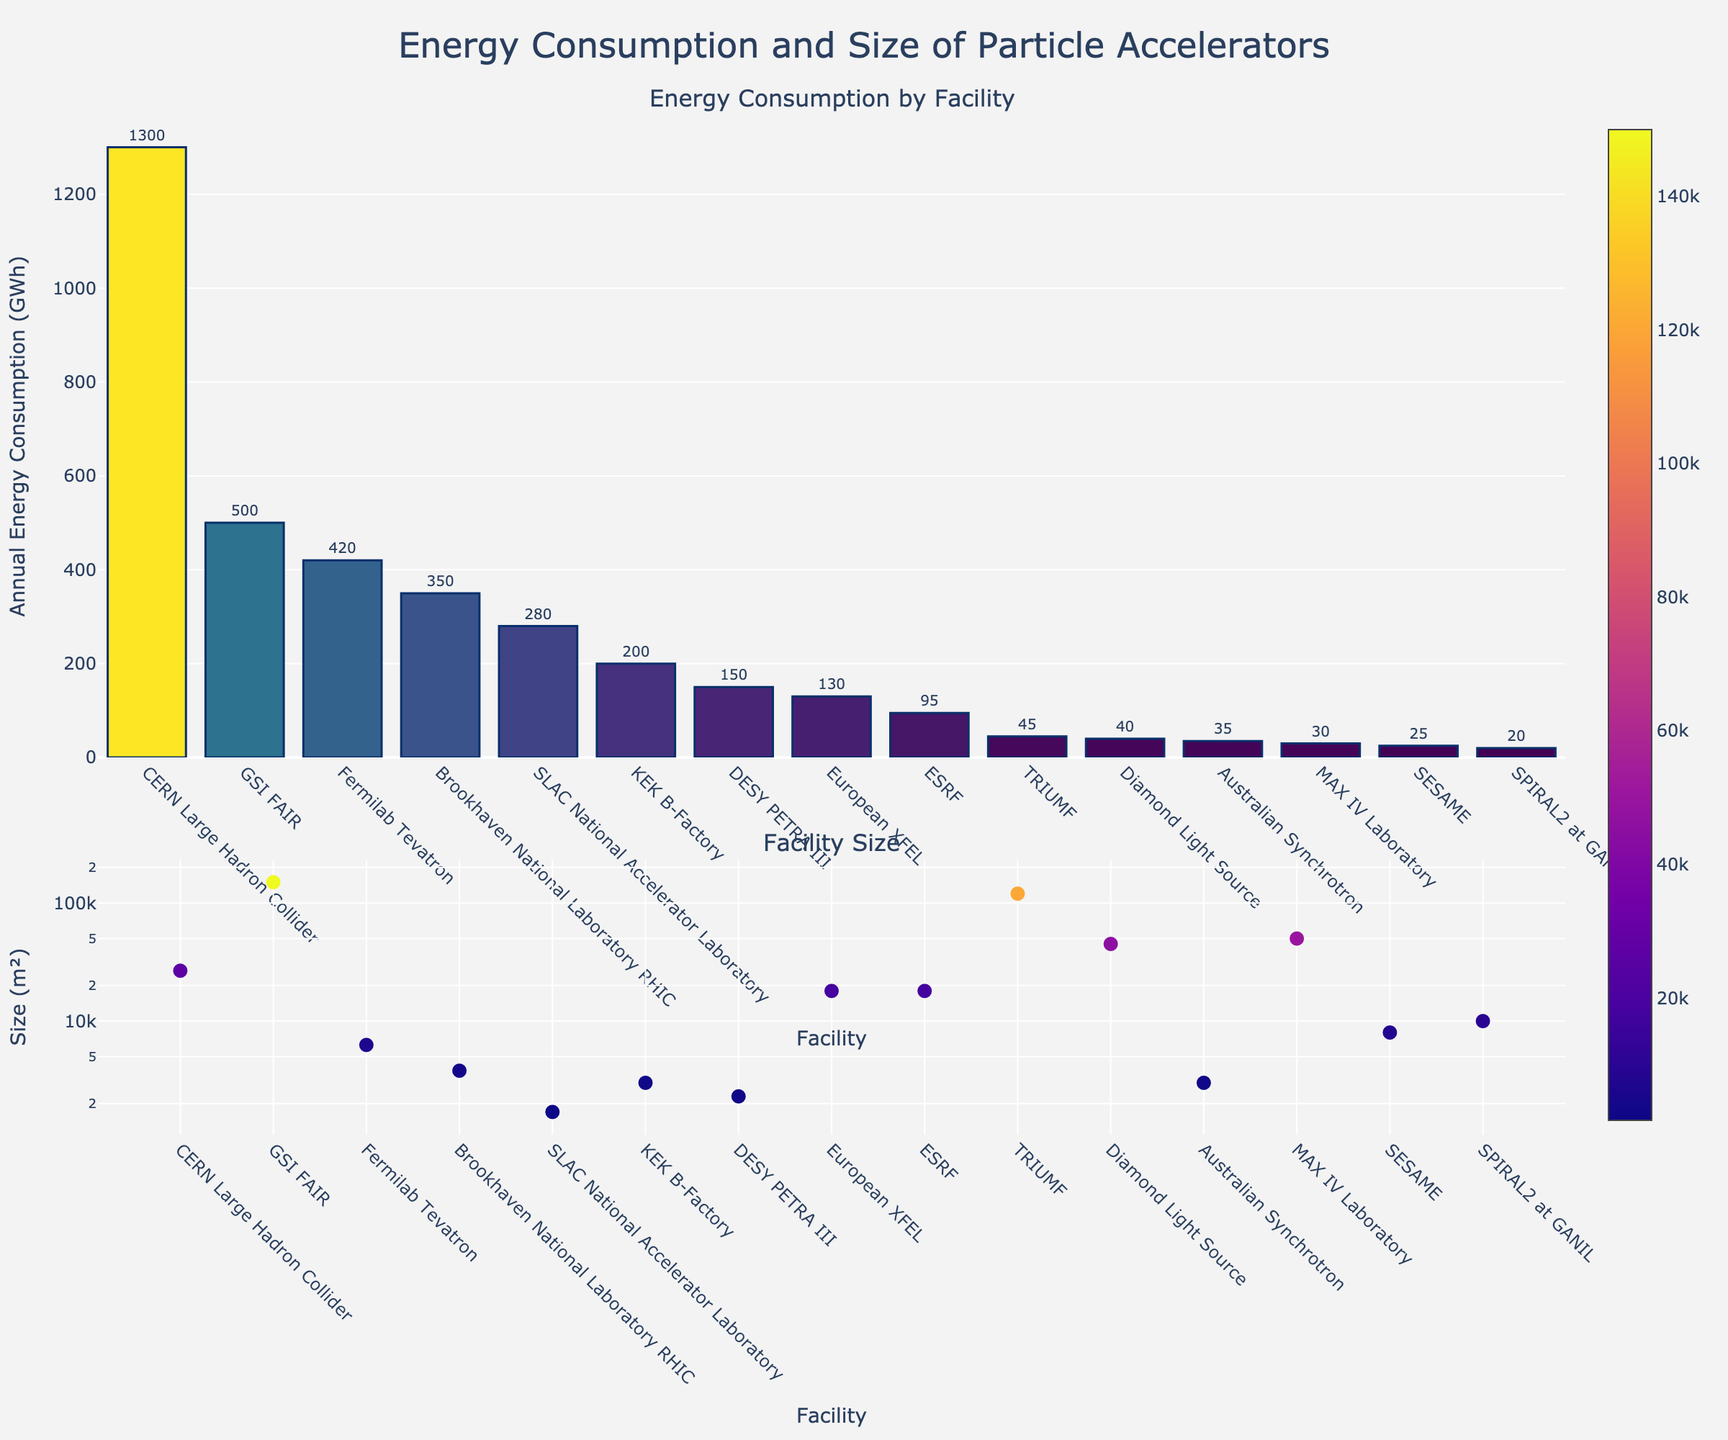What's the facility with the highest annual energy consumption? The bar chart for energy consumption shows that the CERN Large Hadron Collider has the tallest bar, indicating the highest annual energy consumption.
Answer: CERN Large Hadron Collider How does the energy consumption of Fermilab Tevatron compare to SLAC National Accelerator Laboratory? The bar for Fermilab Tevatron is higher than the bar for SLAC National Accelerator Laboratory, indicating that Fermilab Tevatron consumes more energy annually.
Answer: Fermilab Tevatron consumes more energy Which facility has the largest size? The scatter plot for facility size shows that GSI FAIR has the highest value, indicating that it has the largest size in square meters.
Answer: GSI FAIR What is the combined annual energy consumption of the European XFEL and ESRF? From the bar chart, the European XFEL consumes 130 GWh annually, and the ESRF consumes 95 GWh annually. Combined, they consume 130 + 95 = 225 GWh.
Answer: 225 GWh Which facility between MAX IV Laboratory and Diamond Light Source has a higher energy consumption and how much more? From the bar chart, Diamond Light Source consumes 40 GWh and MAX IV Laboratory consumes 30 GWh. Diamond Light Source consumes 40 - 30 = 10 GWh more.
Answer: Diamond Light Source, 10 GWh more What is the median size of the facilities? To find the median size, list the sizes in ascending order and find the middle value. Sorted sizes are: 1700, 2304, 26700, 3000, 3000, 3800, 45000, 50000, 6280, 8000, 10000, 120000, 150000. The middle value is the 7th one: 3800 m².
Answer: 3800 m² Which facility has the smallest energy consumption and how does it compare to SESAME? The bar for SPIRAL2 at GANIL is the shortest, indicating the smallest energy consumption at 20 GWh. SESAME consumes 25 GWh, so SPIRAL2 at GANIL consumes 25 - 20 = 5 GWh less.
Answer: SPIRAL2 at GANIL, 5 GWh less What is the approximate average annual energy consumption of all the facilities? Sum the energy consumptions and divide by the number of facilities. (1300+420+280+350+150+200+500+45+130+95+40+35+25+30+20)/15 = 3600/15 = 240 GWh.
Answer: 240 GWh What is the color progression used for the bars representing energy consumption? The bars use a color gradient from dark blue for the smallest values to yellow for the largest values, indicating the Viridis color scale.
Answer: Dark blue to yellow How many facilities have sizes exceeding 100,000 m²? From the scatter plot, GSI FAIR and TRIUMF exceed 100,000 m².
Answer: 2 